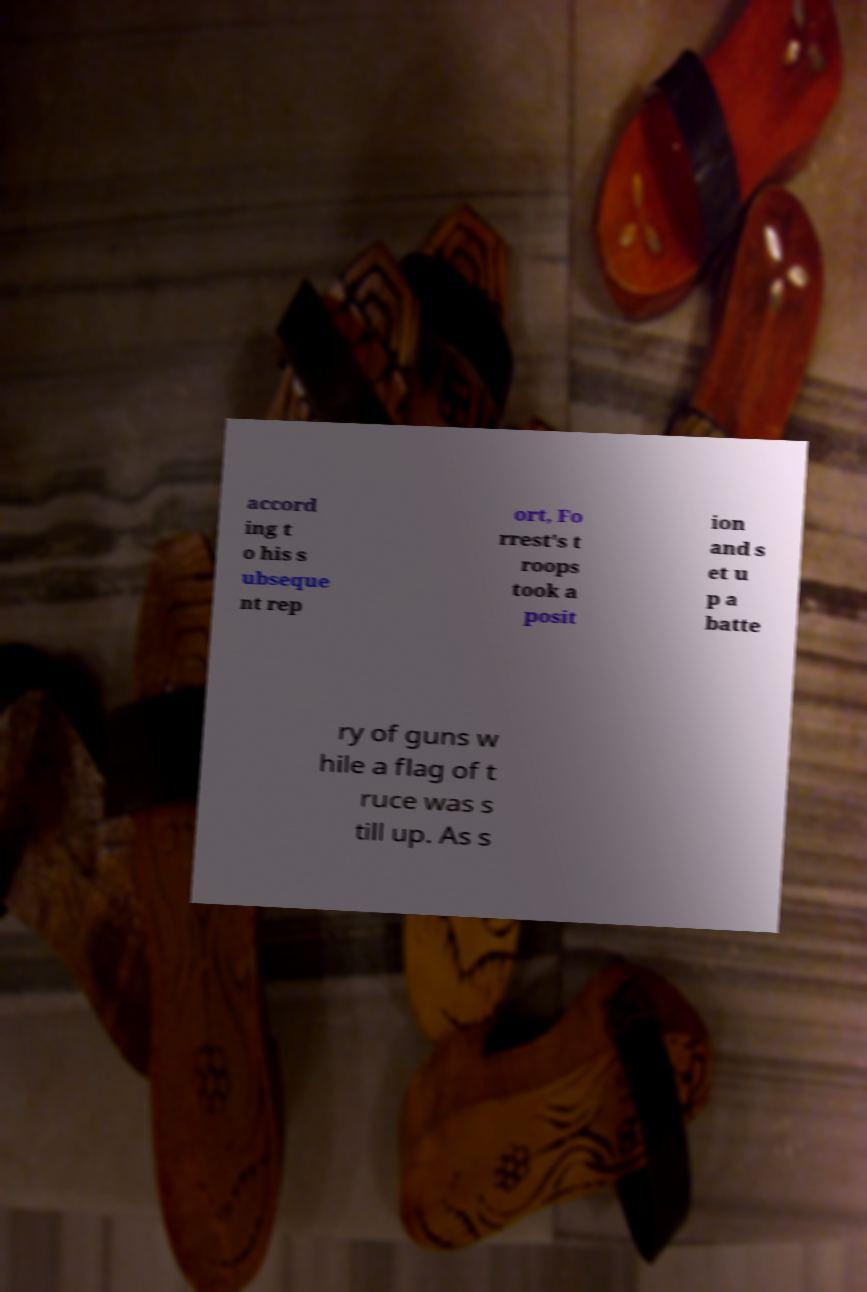Please identify and transcribe the text found in this image. accord ing t o his s ubseque nt rep ort, Fo rrest's t roops took a posit ion and s et u p a batte ry of guns w hile a flag of t ruce was s till up. As s 